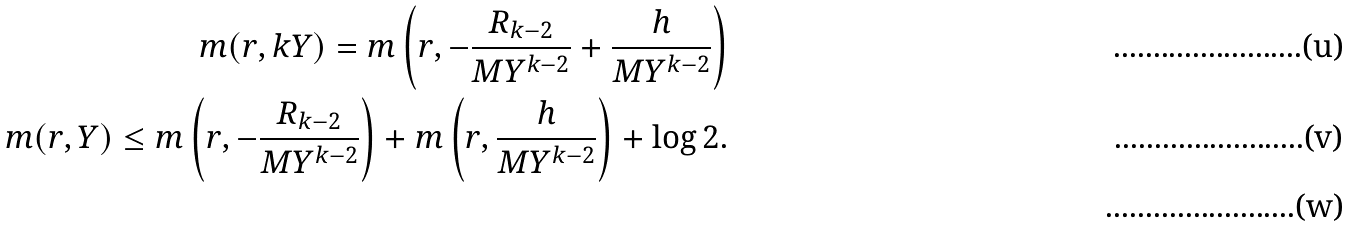Convert formula to latex. <formula><loc_0><loc_0><loc_500><loc_500>m ( r , k Y ) = m \left ( r , - \frac { R _ { k - 2 } } { M Y ^ { k - 2 } } + \frac { h } { M Y ^ { k - 2 } } \right ) \\ m ( r , Y ) \leq m \left ( r , - \frac { R _ { k - 2 } } { M Y ^ { k - 2 } } \right ) + m \left ( r , \frac { h } { M Y ^ { k - 2 } } \right ) + \log 2 . \\ &</formula> 